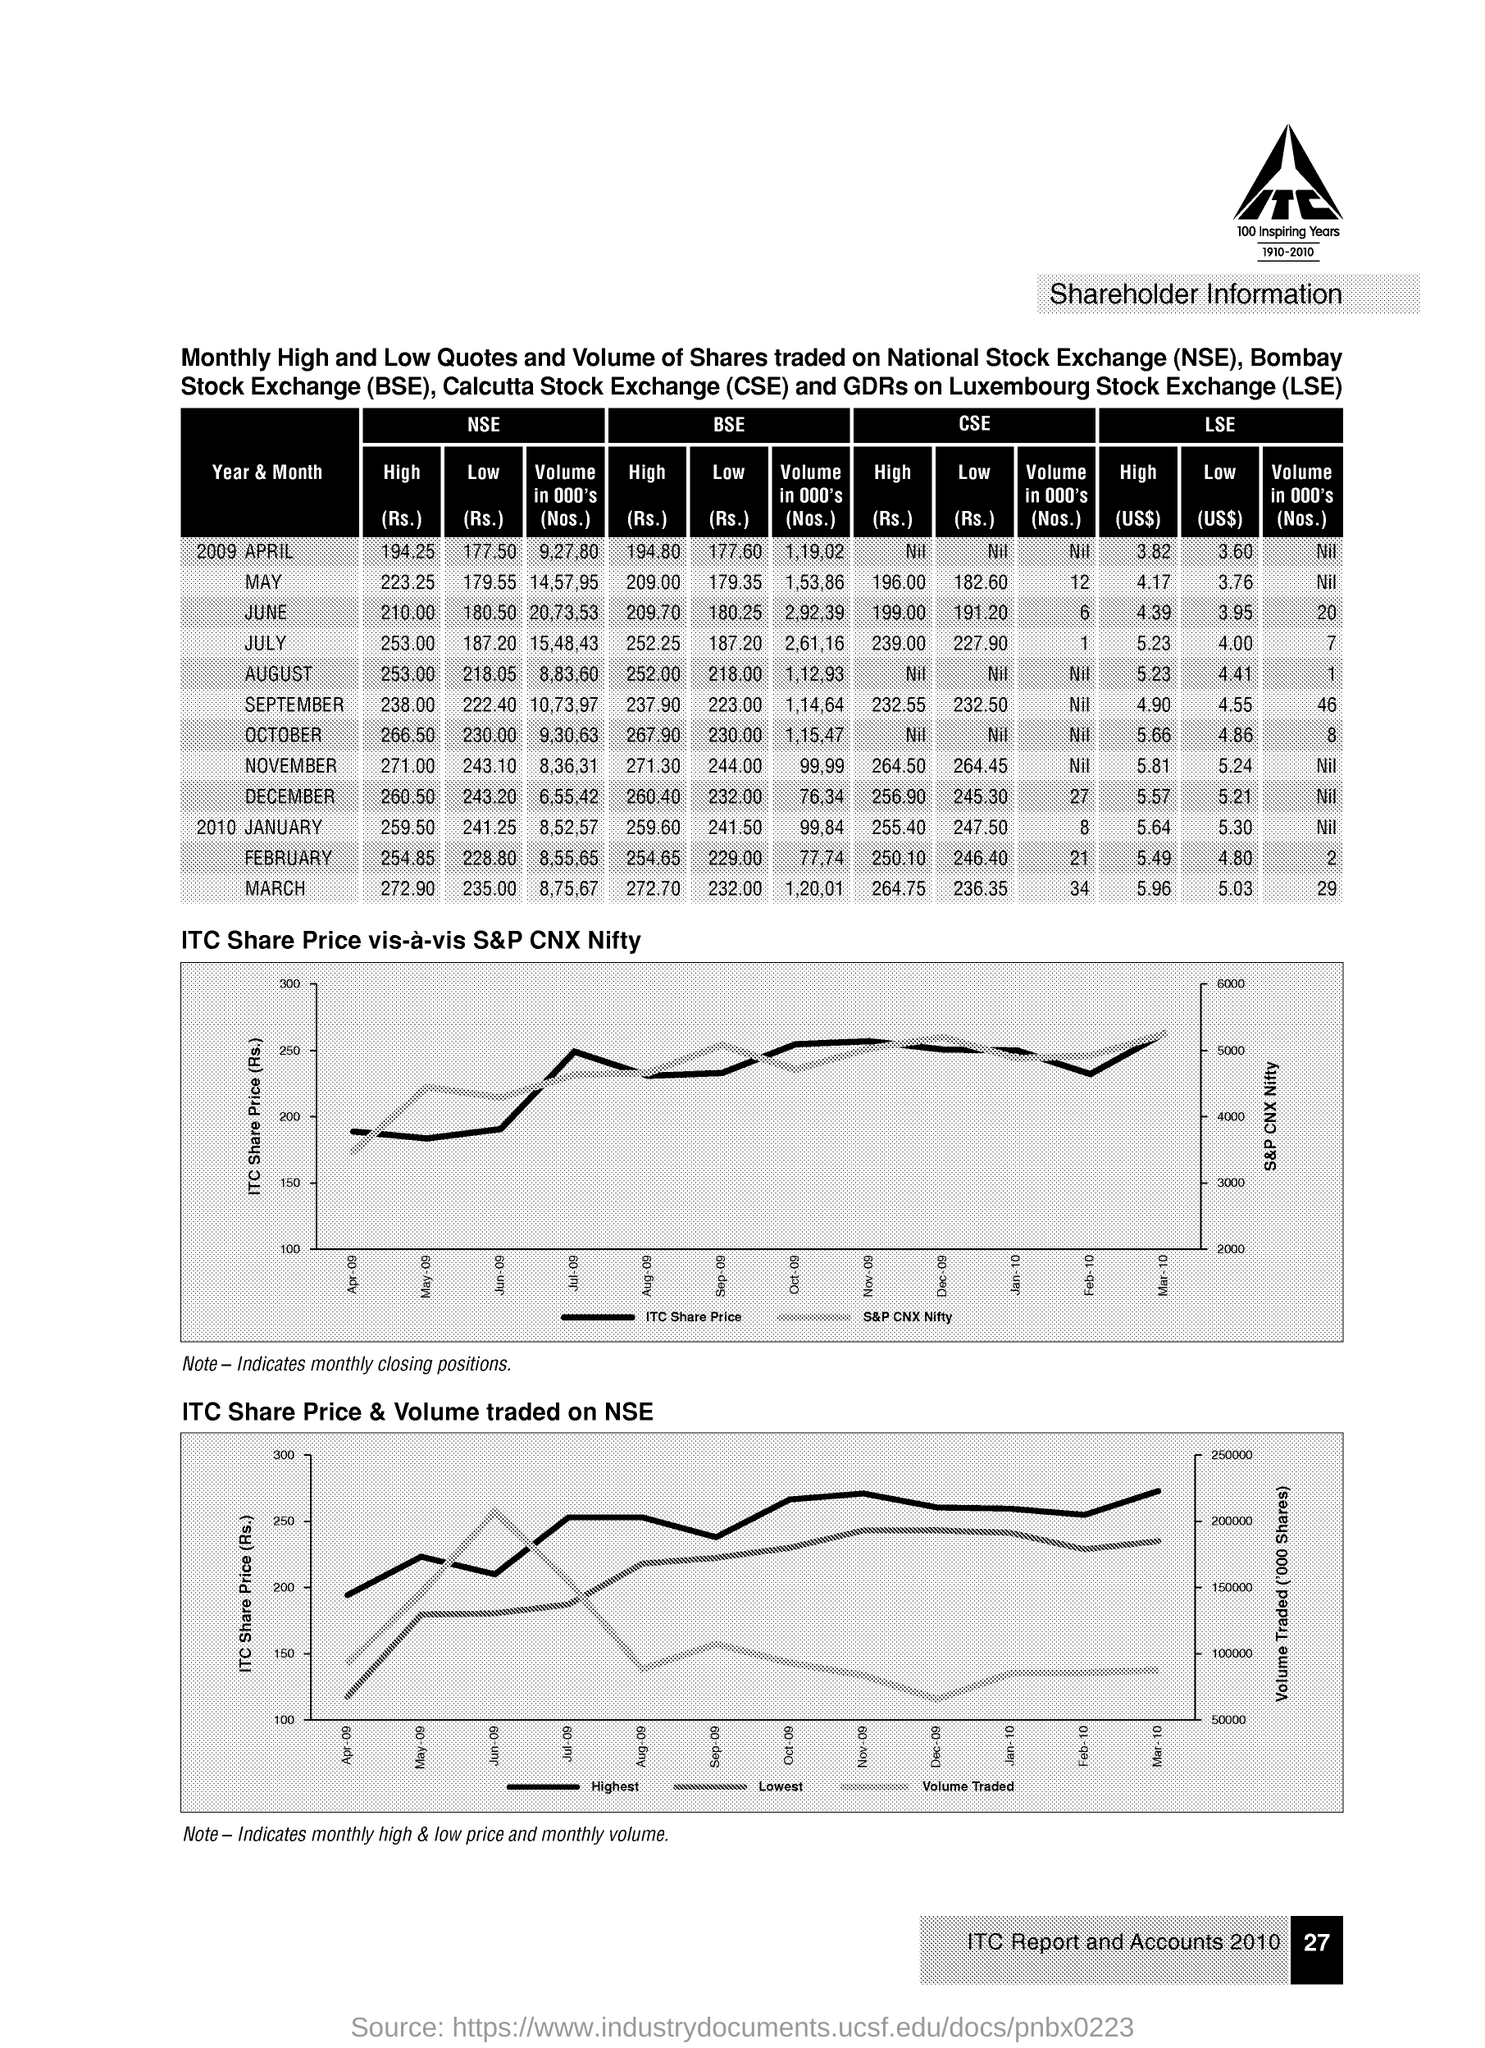Identify some key points in this picture. In April 2009, the high price of NSE was 194.25 Rupees. The full form of BSE is Bombay Stock Exchange. The full form of NSE is the National Stock Exchange. The volume in 000's(No's) of LSE for the year & month 2009 December was nil. The full form of CSE is the Calcutta Stock Exchange, which is a stock exchange located in Kolkata, India. 